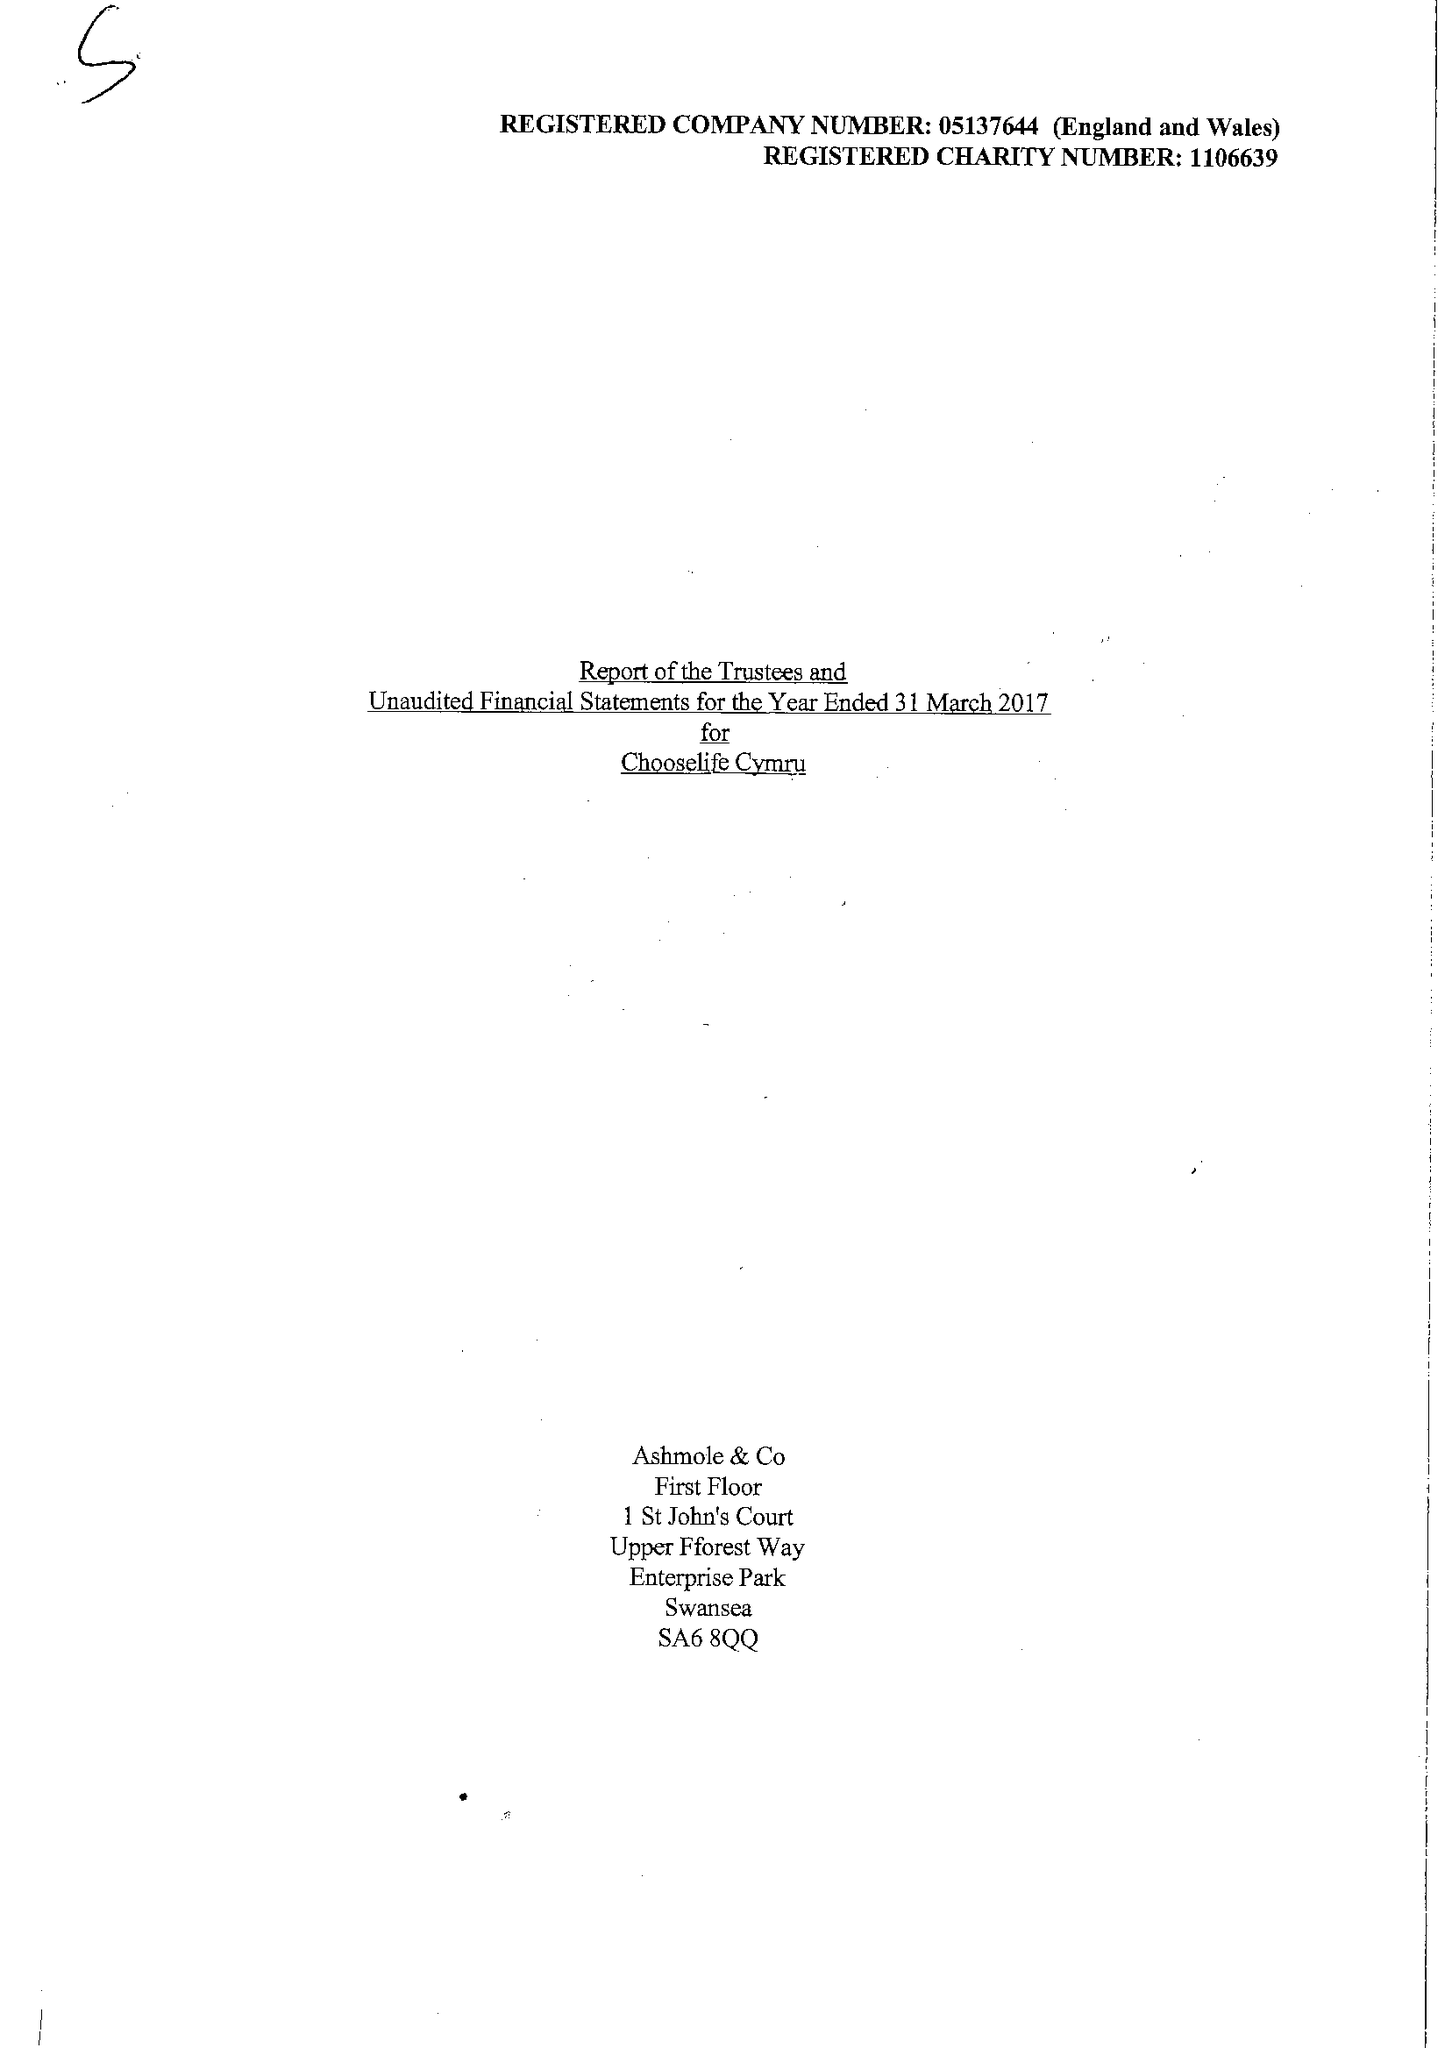What is the value for the income_annually_in_british_pounds?
Answer the question using a single word or phrase. 346343.00 